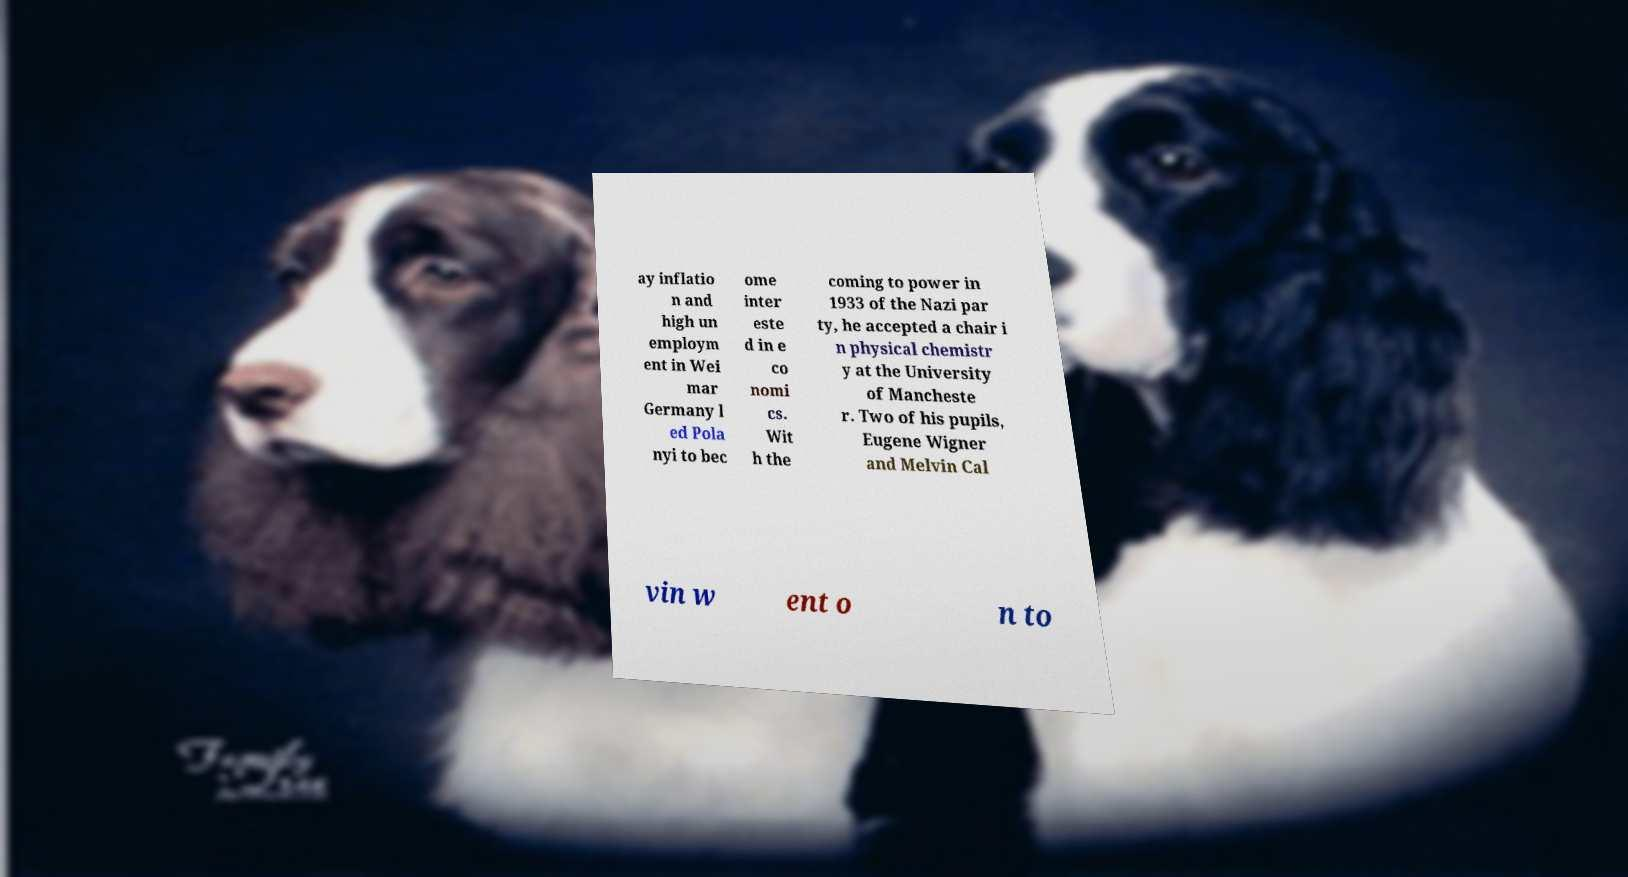What messages or text are displayed in this image? I need them in a readable, typed format. ay inflatio n and high un employm ent in Wei mar Germany l ed Pola nyi to bec ome inter este d in e co nomi cs. Wit h the coming to power in 1933 of the Nazi par ty, he accepted a chair i n physical chemistr y at the University of Mancheste r. Two of his pupils, Eugene Wigner and Melvin Cal vin w ent o n to 